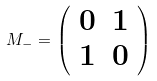<formula> <loc_0><loc_0><loc_500><loc_500>M _ { - } = \left ( \begin{array} { c c } 0 & 1 \\ 1 & 0 \end{array} \right )</formula> 